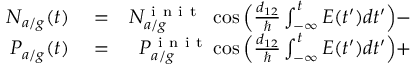Convert formula to latex. <formula><loc_0><loc_0><loc_500><loc_500>\begin{array} { r l r } { N _ { a / g } ( t ) } & = } & { N _ { a / g } ^ { i n i t } \ \cos \left ( \frac { d _ { 1 2 } } { } \int _ { - \infty } ^ { t } E ( t ^ { \prime } ) d t ^ { \prime } \right ) - } \\ { P _ { a / g } ( t ) } & = } & { P _ { a / g } ^ { i n i t } \cos \left ( \frac { d _ { 1 2 } } { } \int _ { - \infty } ^ { t } E ( t ^ { \prime } ) d t ^ { \prime } \right ) + } \end{array}</formula> 